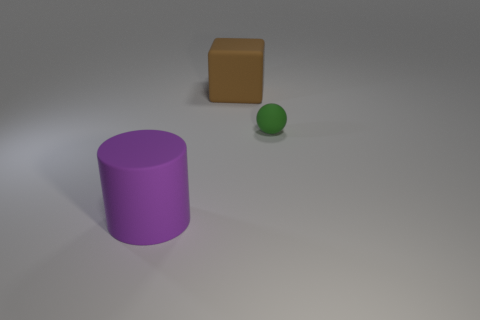Add 2 large purple things. How many objects exist? 5 Subtract all spheres. How many objects are left? 2 Add 2 big brown cubes. How many big brown cubes are left? 3 Add 1 big brown things. How many big brown things exist? 2 Subtract 1 purple cylinders. How many objects are left? 2 Subtract all red metallic things. Subtract all small green balls. How many objects are left? 2 